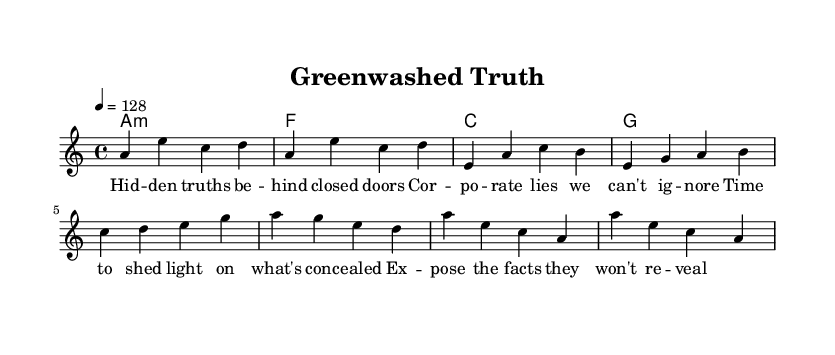What is the key signature of this music? The key signature is A minor, indicated by one sharp (the G#), which is associated with its relative major C major. This is deduced from the initial setup in the global section that specifies the key.
Answer: A minor What is the time signature of this music? The time signature is 4/4, which means there are four beats in each measure and each beat is a quarter note. This can be observed in the global section that specifies the time.
Answer: 4/4 What is the tempo marking for this piece? The tempo marking indicates a speed of 128 beats per minute, which is specified in the global setup. This defines how fast the piece should be played.
Answer: 128 How many measures are there in the verse? The verse consists of four measures, as counted from the melody section where it begins with the notes e, a, c, b and continues for three additional measures following that.
Answer: 4 What is the first note of the drop section? The first note of the drop section is A, which can be identified as the first note in the line that states "a'4 e c a" in the melody.
Answer: A Which lyric line mentions "truths"? The lyric line that mentions "truths" is the first line of the lyrics: "Hid -- den truths be -- hind closed doors." The mention of "truths" specifies the focus of the lyrics regarding corporate accountability.
Answer: Hid -- den truths be -- hind closed doors What is the chord progression used in the harmonies? The chord progression is A minor to F to C to G, which is identifiable from the harmonies section that outlines the transitioning chords in sequence.
Answer: A minor, F, C, G 